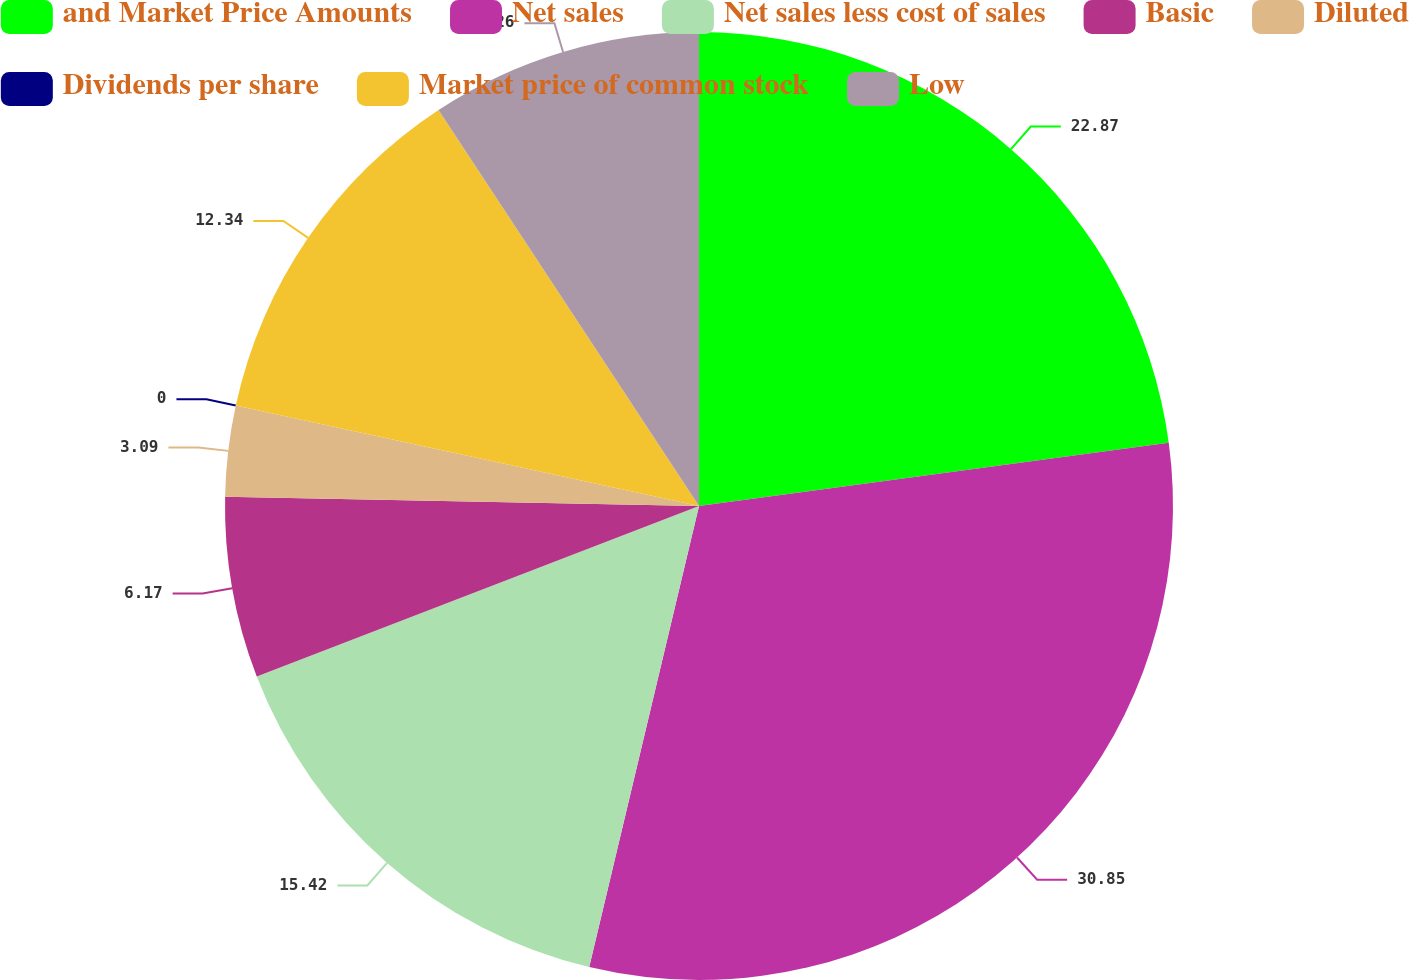<chart> <loc_0><loc_0><loc_500><loc_500><pie_chart><fcel>and Market Price Amounts<fcel>Net sales<fcel>Net sales less cost of sales<fcel>Basic<fcel>Diluted<fcel>Dividends per share<fcel>Market price of common stock<fcel>Low<nl><fcel>22.87%<fcel>30.85%<fcel>15.42%<fcel>6.17%<fcel>3.09%<fcel>0.0%<fcel>12.34%<fcel>9.26%<nl></chart> 